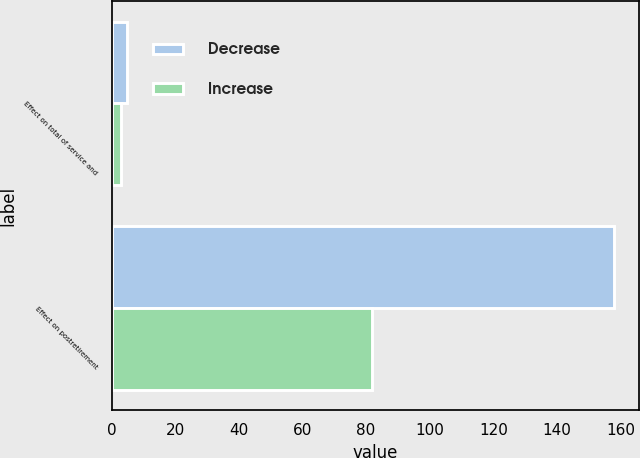Convert chart to OTSL. <chart><loc_0><loc_0><loc_500><loc_500><stacked_bar_chart><ecel><fcel>Effect on total of service and<fcel>Effect on postretirement<nl><fcel>Decrease<fcel>5<fcel>158<nl><fcel>Increase<fcel>3<fcel>82<nl></chart> 